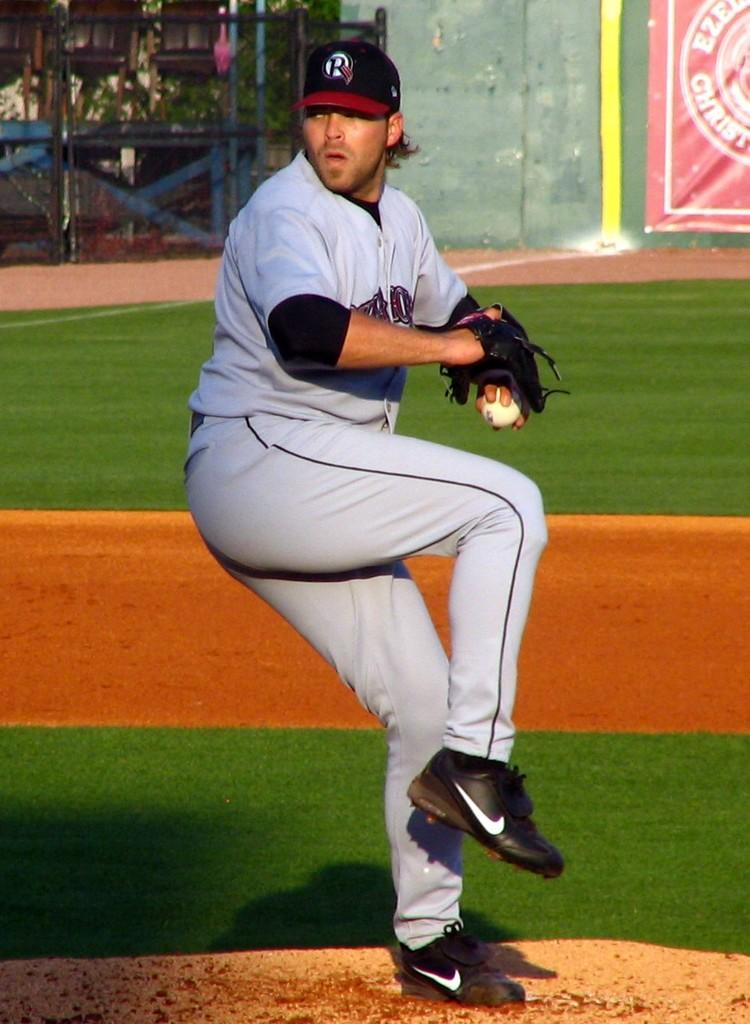<image>
Give a short and clear explanation of the subsequent image. Baesball player wearing a cap with the letter R about to pitch. 